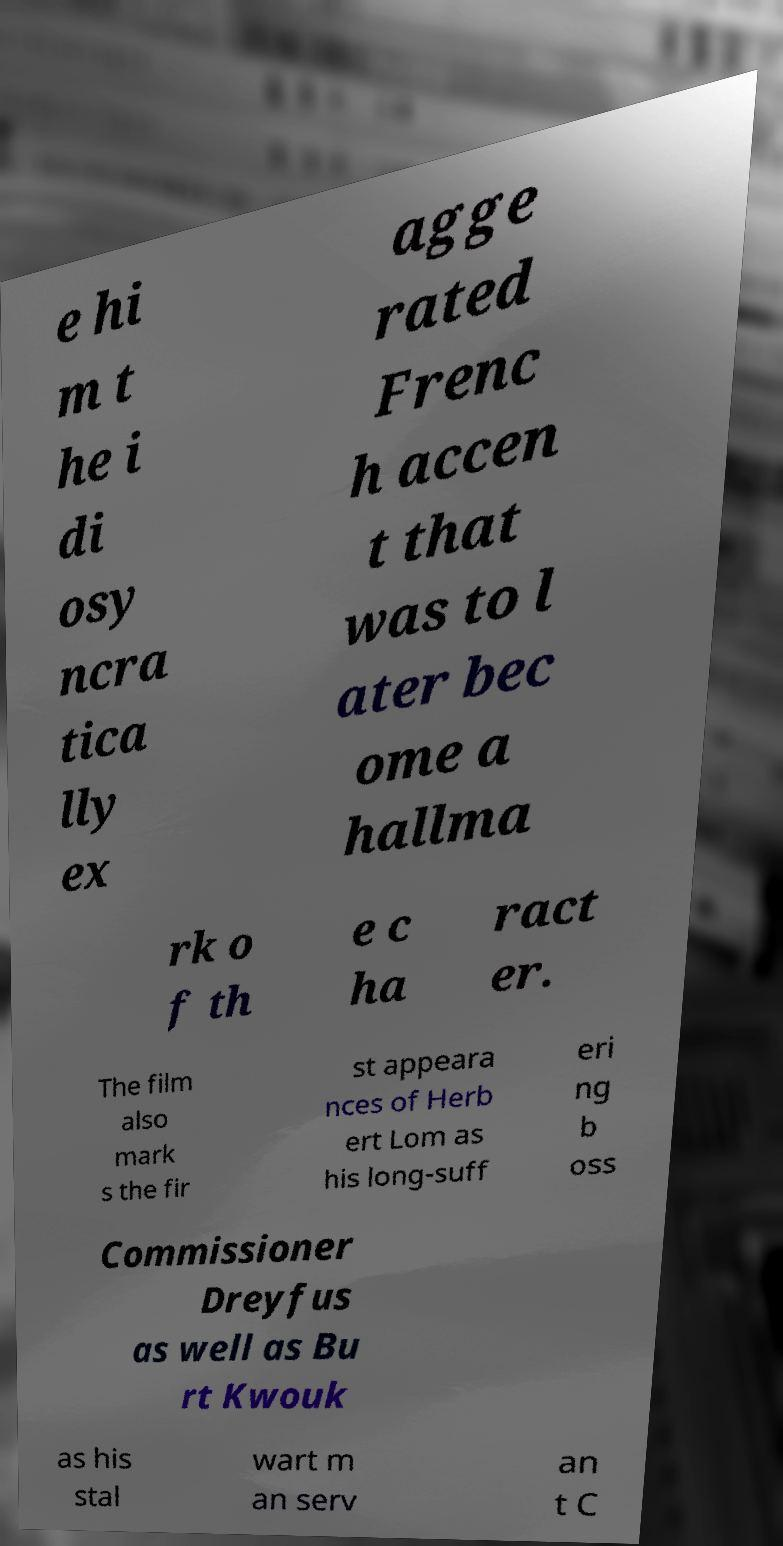Please read and relay the text visible in this image. What does it say? e hi m t he i di osy ncra tica lly ex agge rated Frenc h accen t that was to l ater bec ome a hallma rk o f th e c ha ract er. The film also mark s the fir st appeara nces of Herb ert Lom as his long-suff eri ng b oss Commissioner Dreyfus as well as Bu rt Kwouk as his stal wart m an serv an t C 